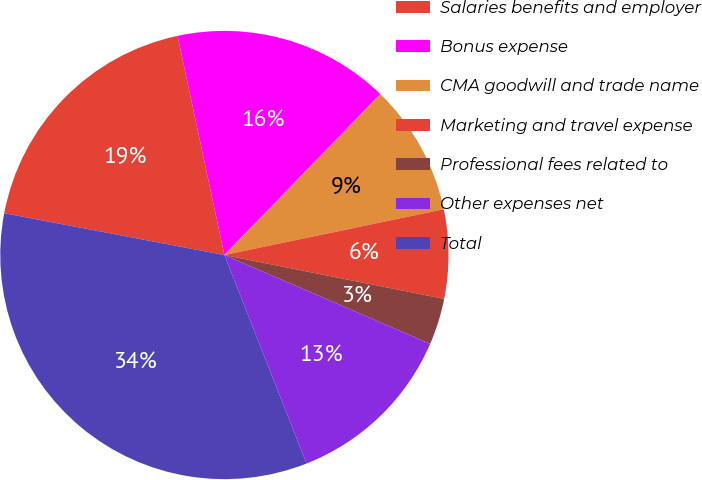Convert chart to OTSL. <chart><loc_0><loc_0><loc_500><loc_500><pie_chart><fcel>Salaries benefits and employer<fcel>Bonus expense<fcel>CMA goodwill and trade name<fcel>Marketing and travel expense<fcel>Professional fees related to<fcel>Other expenses net<fcel>Total<nl><fcel>18.66%<fcel>15.6%<fcel>9.48%<fcel>6.41%<fcel>3.35%<fcel>12.54%<fcel>33.96%<nl></chart> 